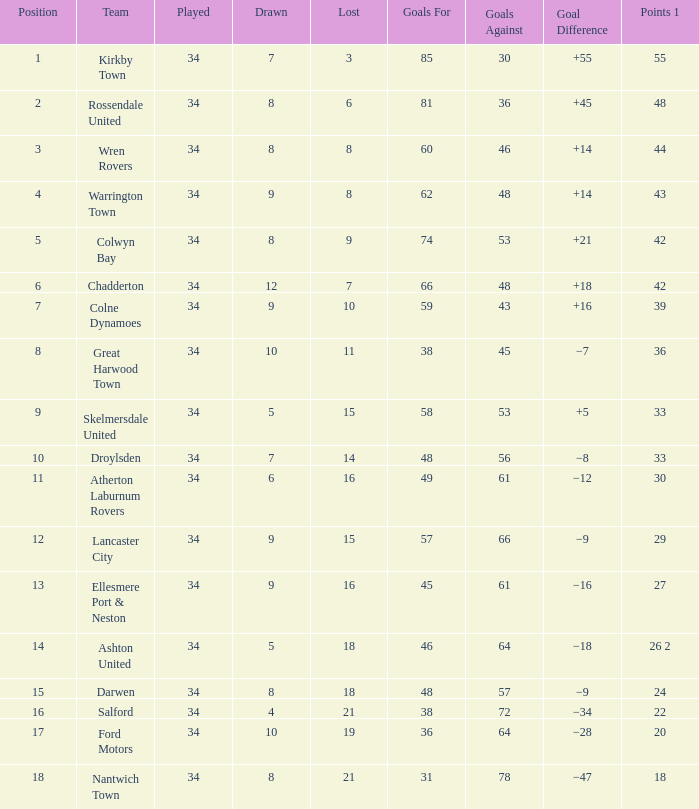What is the cumulative number of goals when there are less than 7 draws, no more than 20 lost games, and a single point from 33 possible? 1.0. 